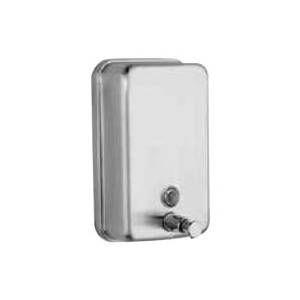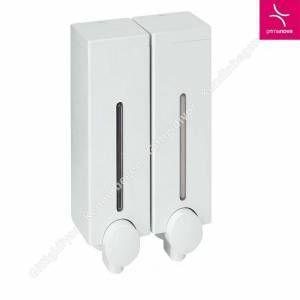The first image is the image on the left, the second image is the image on the right. Examine the images to the left and right. Is the description "There are four soap dispensers in total." accurate? Answer yes or no. No. The first image is the image on the left, the second image is the image on the right. For the images shown, is this caption "An image shows at least two side-by-side dispensers that feature a chrome T-shaped bar underneath." true? Answer yes or no. No. 